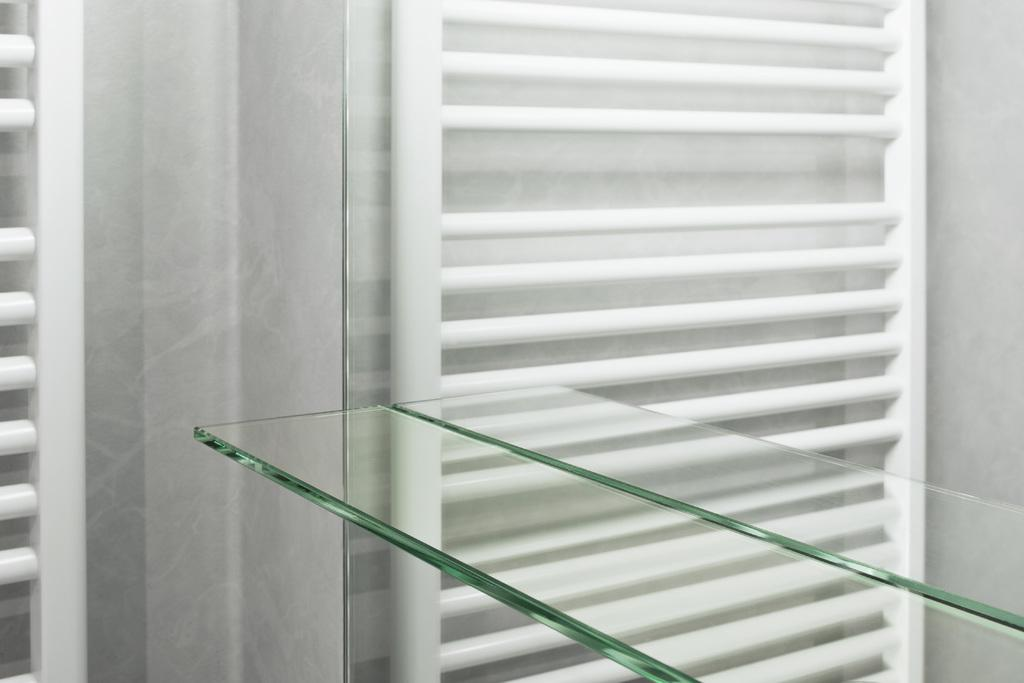Where was the image taken? The image was taken in a room. What can be seen on the right side of the image? There is a glass on the right side of the image. What is visible in the background of the image? There is a girl and a wall in the background of the image. What type of bird is sitting on the clock in the image? There is no clock or bird present in the image. What number is written on the wall in the image? There is no number visible on the wall in the image. 